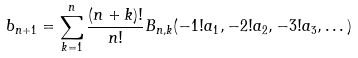Convert formula to latex. <formula><loc_0><loc_0><loc_500><loc_500>b _ { n + 1 } = \sum _ { k = 1 } ^ { n } \frac { ( n + k ) ! } { n ! } B _ { n , k } ( - 1 ! a _ { 1 } , - 2 ! a _ { 2 } , - 3 ! a _ { 3 } , \dots )</formula> 